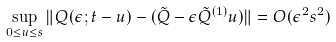Convert formula to latex. <formula><loc_0><loc_0><loc_500><loc_500>\sup _ { 0 \leq u \leq s } \| Q ( \epsilon ; t - u ) - ( \tilde { Q } - \epsilon \tilde { Q } ^ { ( 1 ) } u ) \| = O ( \epsilon ^ { 2 } s ^ { 2 } )</formula> 